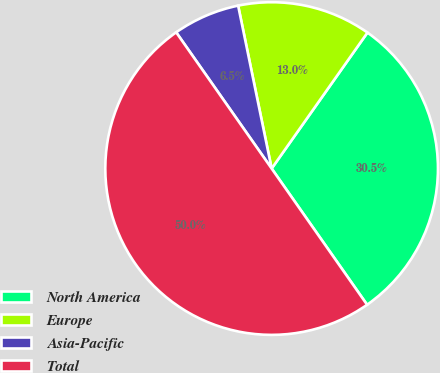<chart> <loc_0><loc_0><loc_500><loc_500><pie_chart><fcel>North America<fcel>Europe<fcel>Asia-Pacific<fcel>Total<nl><fcel>30.5%<fcel>13.0%<fcel>6.5%<fcel>50.0%<nl></chart> 